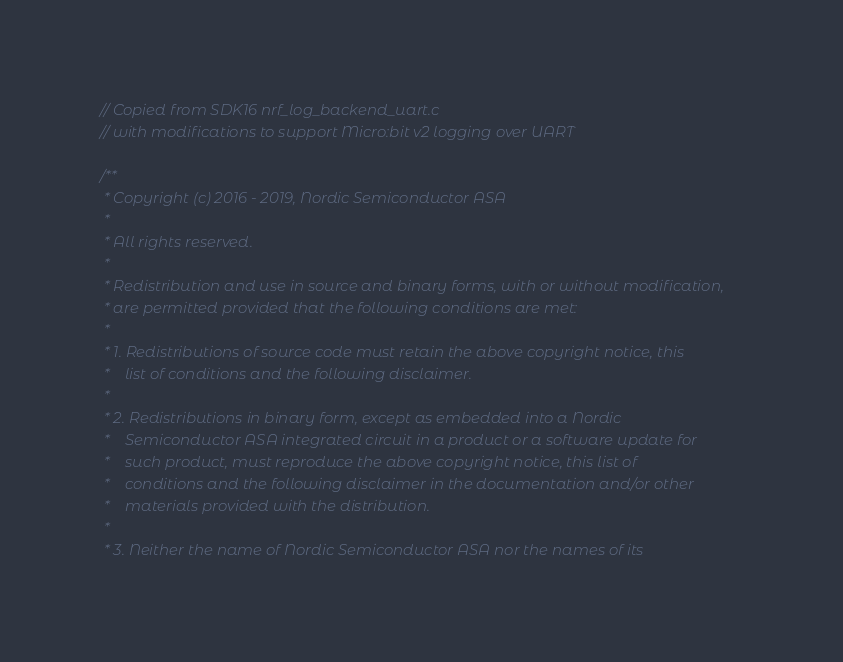<code> <loc_0><loc_0><loc_500><loc_500><_C_>// Copied from SDK16 nrf_log_backend_uart.c
// with modifications to support Micro:bit v2 logging over UART

/**
 * Copyright (c) 2016 - 2019, Nordic Semiconductor ASA
 *
 * All rights reserved.
 *
 * Redistribution and use in source and binary forms, with or without modification,
 * are permitted provided that the following conditions are met:
 *
 * 1. Redistributions of source code must retain the above copyright notice, this
 *    list of conditions and the following disclaimer.
 *
 * 2. Redistributions in binary form, except as embedded into a Nordic
 *    Semiconductor ASA integrated circuit in a product or a software update for
 *    such product, must reproduce the above copyright notice, this list of
 *    conditions and the following disclaimer in the documentation and/or other
 *    materials provided with the distribution.
 *
 * 3. Neither the name of Nordic Semiconductor ASA nor the names of its</code> 